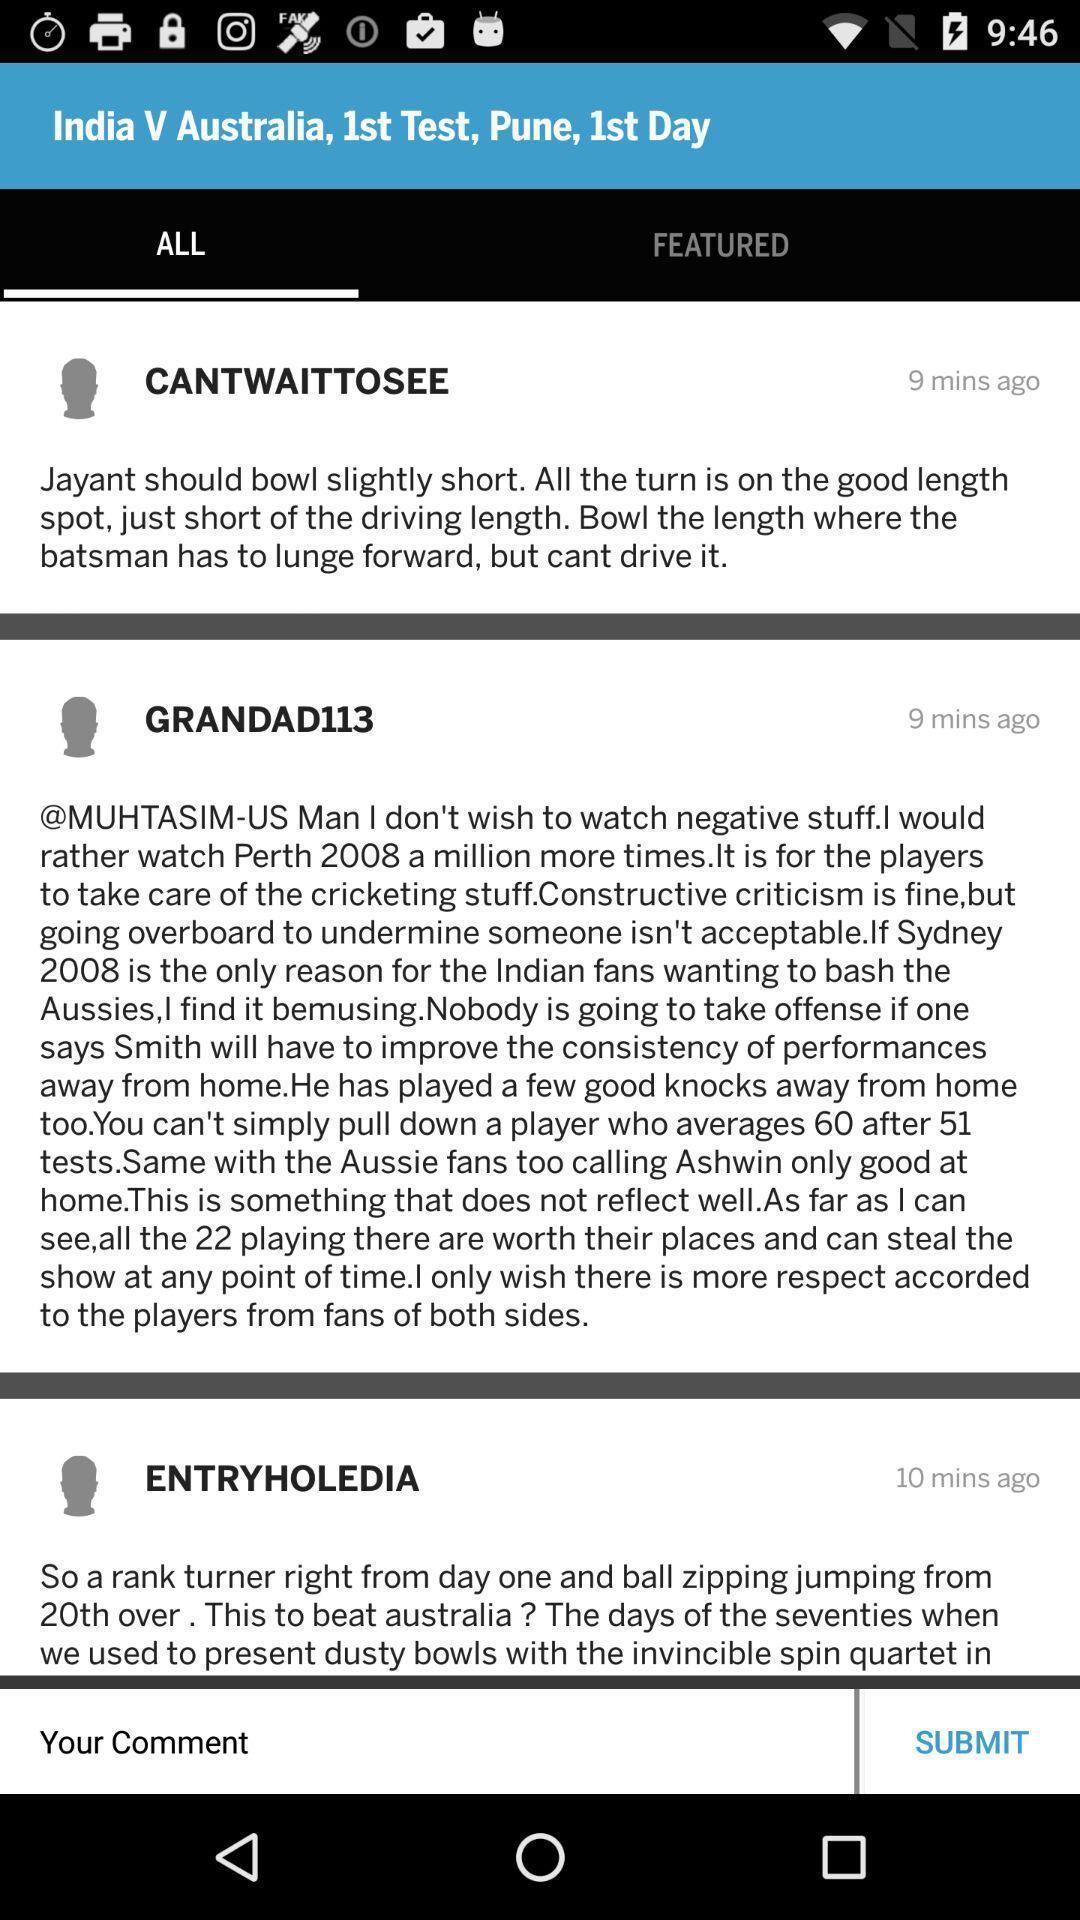Tell me what you see in this picture. Screen displaying comments section in all tab. 